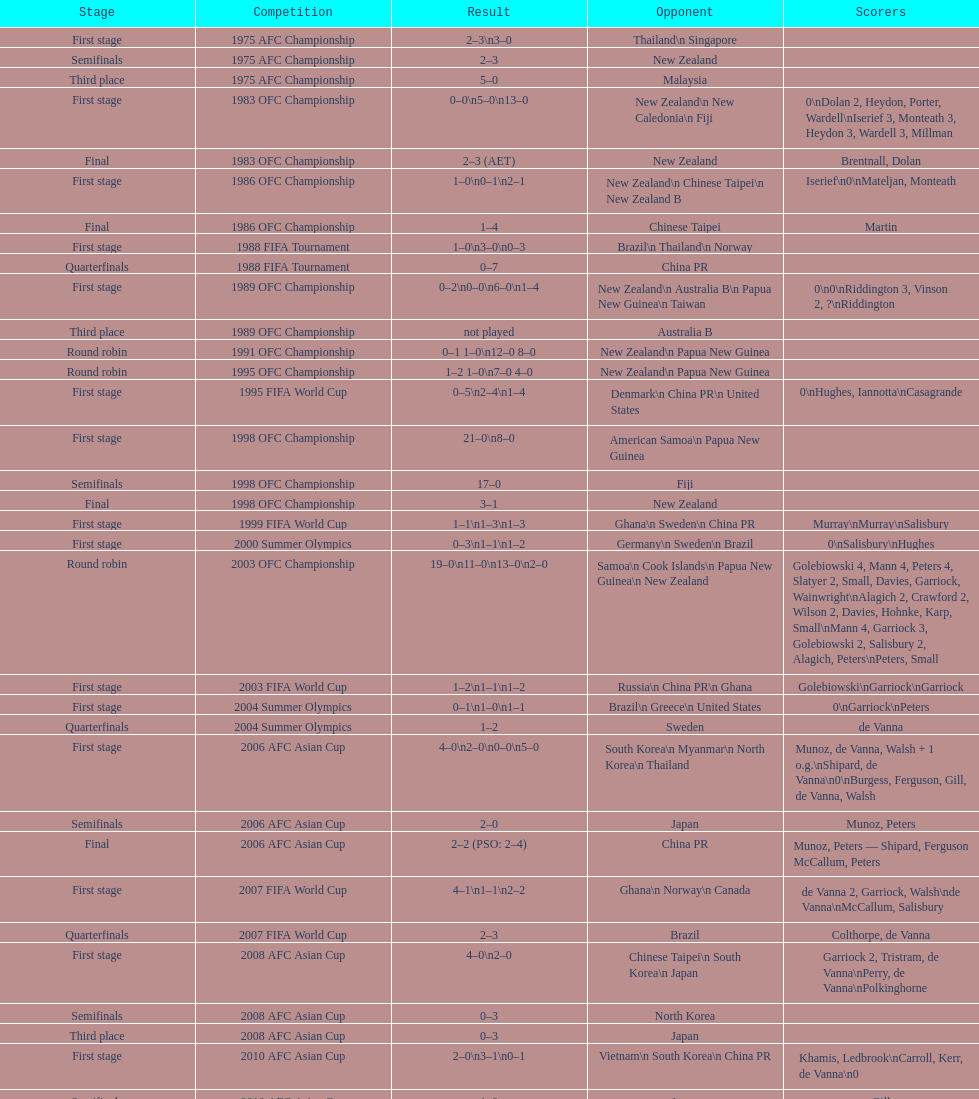How many points were scored in the final round of the 2012 summer olympics afc qualification? 12. 